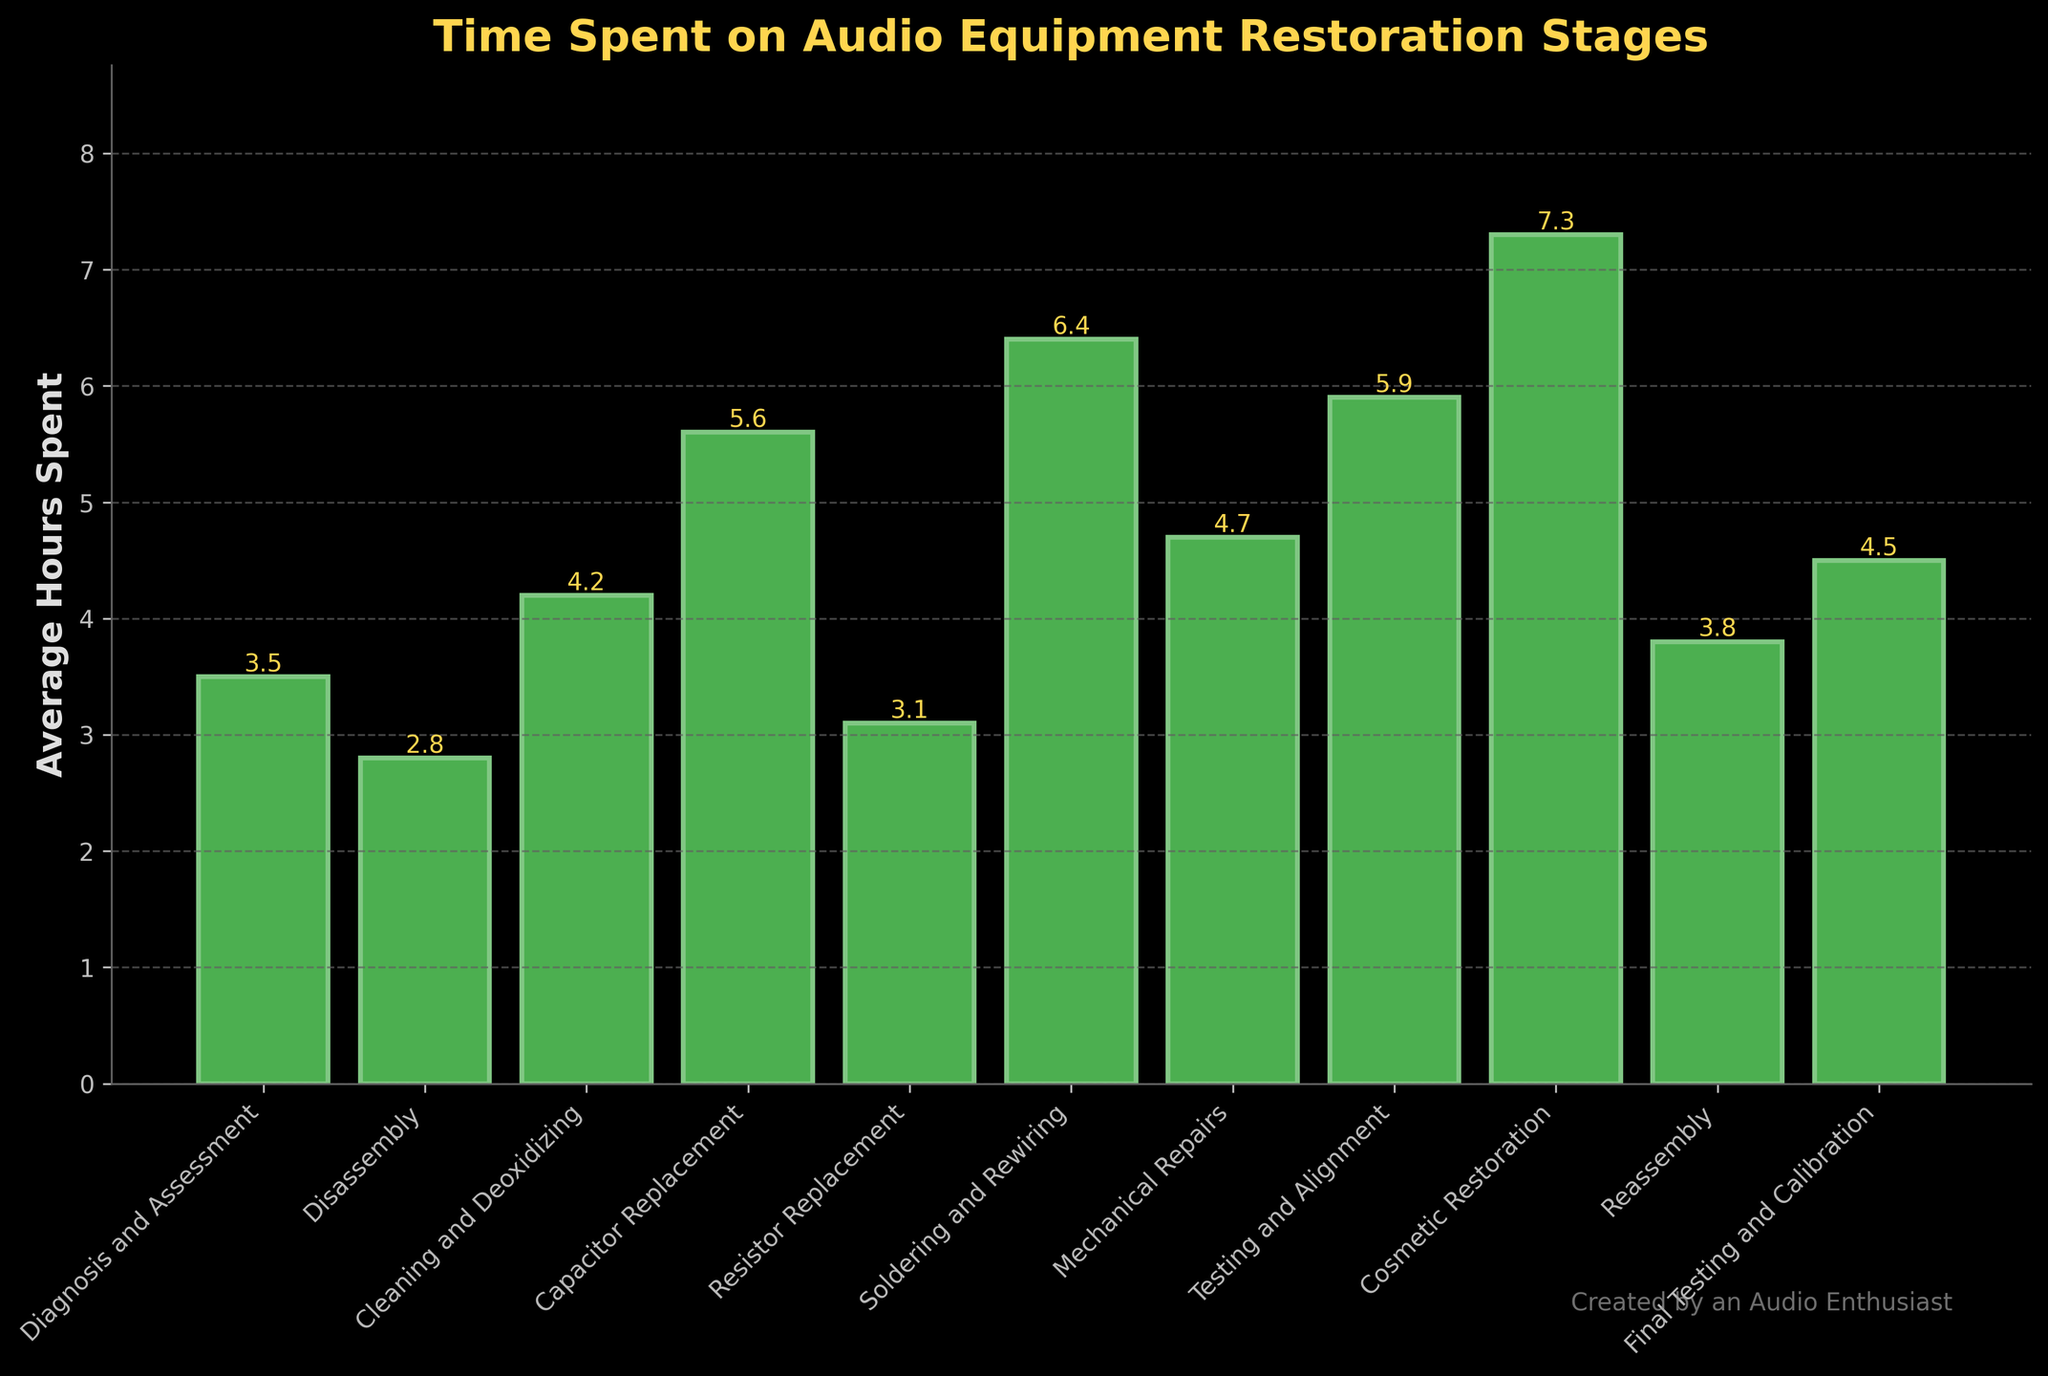Which stage has the highest average hours spent? Look for the tallest bar in the chart, which represents the highest average hours spent.
Answer: Cosmetic Restoration Which stage requires less time, Diagnosis and Assessment or Cleaning and Deoxidizing? Compare the heights of the bars for "Diagnosis and Assessment" and "Cleaning and Deoxidizing." The shorter bar indicates less time.
Answer: Diagnosis and Assessment What is the total time spent on Resistor Replacement and Soldering and Rewiring? Add the average hours spent on "Resistor Replacement" and "Soldering and Rewiring": 3.1 + 6.4.
Answer: 9.5 hours Is more time spent on Mechanical Repairs or Final Testing and Calibration? Compare the heights of the bars for "Mechanical Repairs" and "Final Testing and Calibration." The taller bar indicates more time spent.
Answer: Mechanical Repairs What is the difference in time spent between Disassembly and Reassembly? Subtract the average hours spent on "Disassembly" from those spent on "Reassembly": 3.8 - 2.8.
Answer: 1.0 hour What's the average time spent on Diagnosis and Assessment, Disassembly, and Cleaning and Deoxidizing? Calculate the average by summing the hours and dividing by the number of stages: (3.5 + 2.8 + 4.2) / 3.
Answer: 3.5 hours Which stage has the least average hours spent? Identify the shortest bar in the chart, representing the stage with the least average hours spent.
Answer: Disassembly Compare the time spent on Testing and Alignment versus Final Testing and Calibration. Which one is higher? Compare the heights of the bars for "Testing and Alignment" and "Final Testing and Calibration." The taller bar indicates more time spent.
Answer: Testing and Alignment What is the combined time spent on Capacitor Replacement and Mechanical Repairs? Add the average hours spent on "Capacitor Replacement" and "Mechanical Repairs": 5.6 + 4.7.
Answer: 10.3 hours How many stages have average hours spent greater than 5? Count the number of bars with a height greater than 5 on the Y-axis.
Answer: 5 stages 